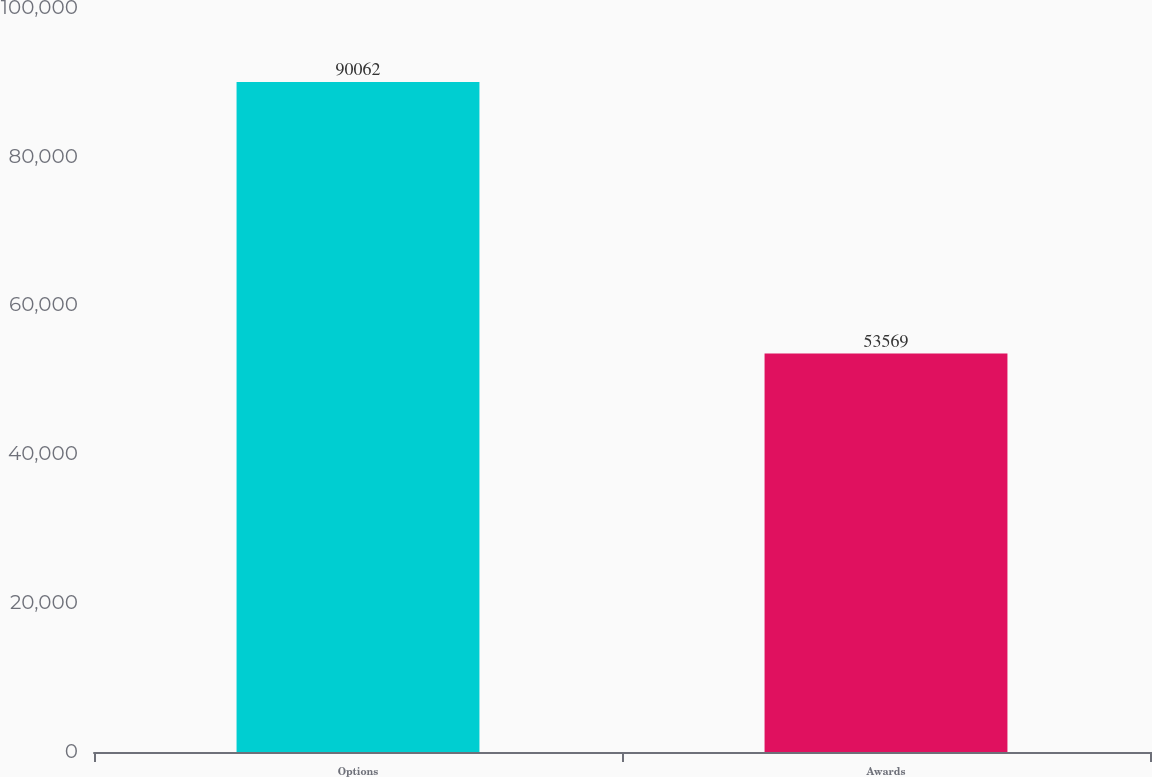Convert chart. <chart><loc_0><loc_0><loc_500><loc_500><bar_chart><fcel>Options<fcel>Awards<nl><fcel>90062<fcel>53569<nl></chart> 